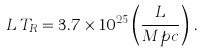Convert formula to latex. <formula><loc_0><loc_0><loc_500><loc_500>L \, T _ { R } = 3 . 7 \times 1 0 ^ { 2 5 } \left ( \frac { L } { M p c } \right ) \, .</formula> 